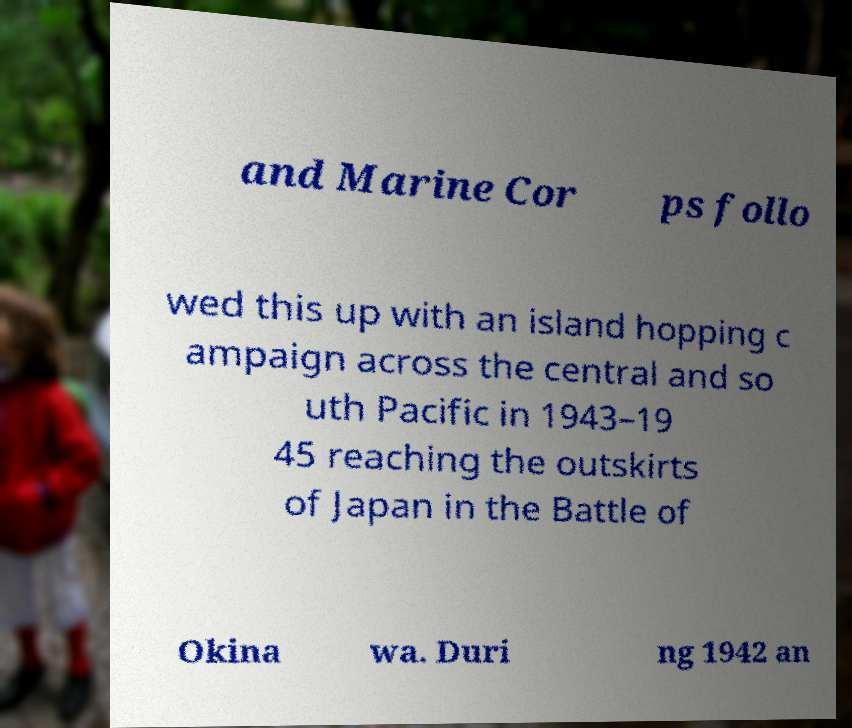What messages or text are displayed in this image? I need them in a readable, typed format. and Marine Cor ps follo wed this up with an island hopping c ampaign across the central and so uth Pacific in 1943–19 45 reaching the outskirts of Japan in the Battle of Okina wa. Duri ng 1942 an 